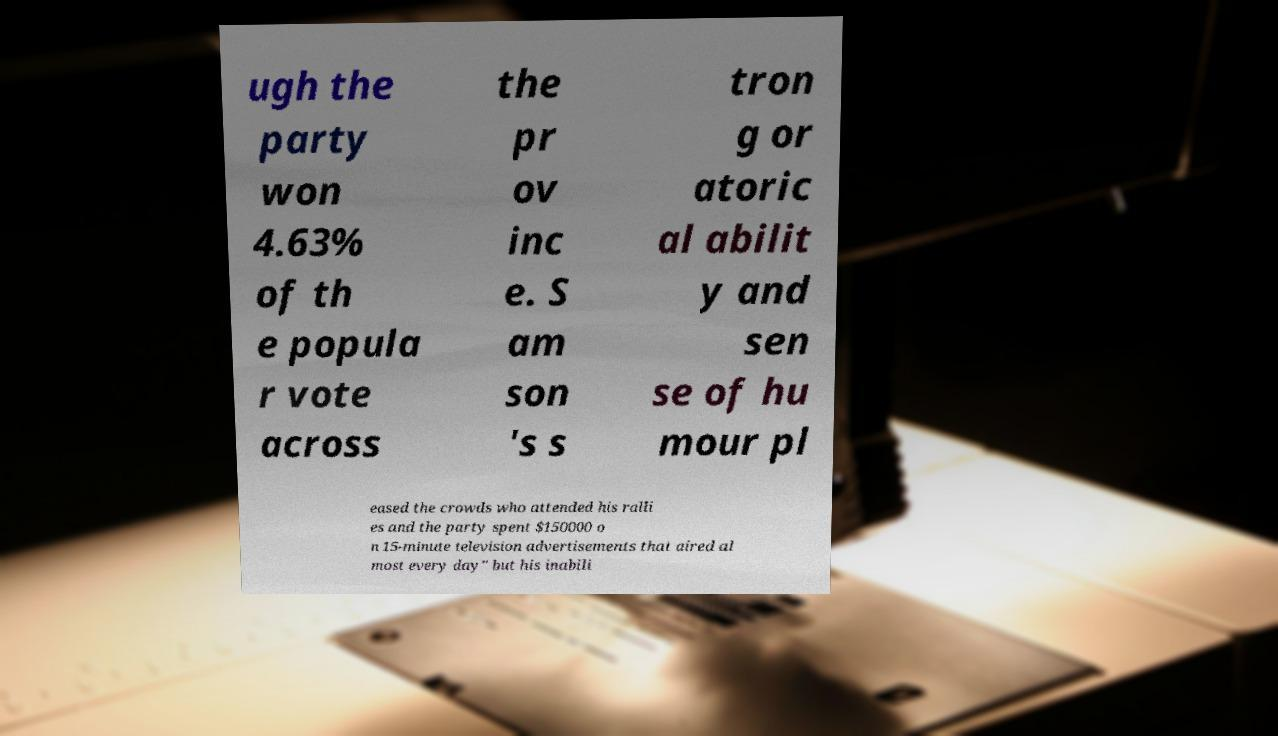Could you assist in decoding the text presented in this image and type it out clearly? ugh the party won 4.63% of th e popula r vote across the pr ov inc e. S am son 's s tron g or atoric al abilit y and sen se of hu mour pl eased the crowds who attended his ralli es and the party spent $150000 o n 15-minute television advertisements that aired al most every day" but his inabili 